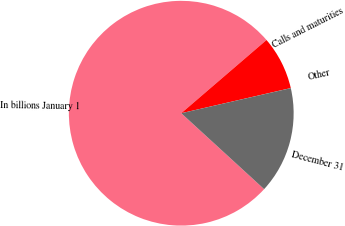Convert chart to OTSL. <chart><loc_0><loc_0><loc_500><loc_500><pie_chart><fcel>In billions January 1<fcel>Calls and maturities<fcel>Other<fcel>December 31<nl><fcel>76.91%<fcel>7.7%<fcel>0.01%<fcel>15.39%<nl></chart> 